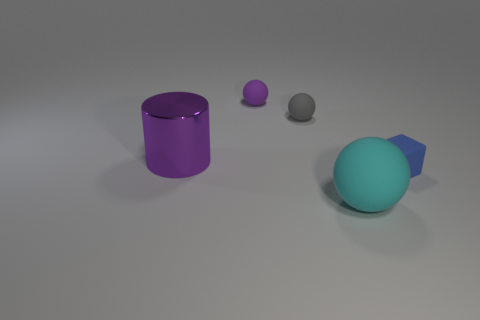Subtract all large balls. How many balls are left? 2 Add 2 big matte balls. How many objects exist? 7 Subtract all balls. How many objects are left? 2 Subtract all brown balls. Subtract all yellow cubes. How many balls are left? 3 Add 4 tiny green rubber balls. How many tiny green rubber balls exist? 4 Subtract 1 purple balls. How many objects are left? 4 Subtract all purple matte objects. Subtract all tiny matte objects. How many objects are left? 1 Add 5 large cyan spheres. How many large cyan spheres are left? 6 